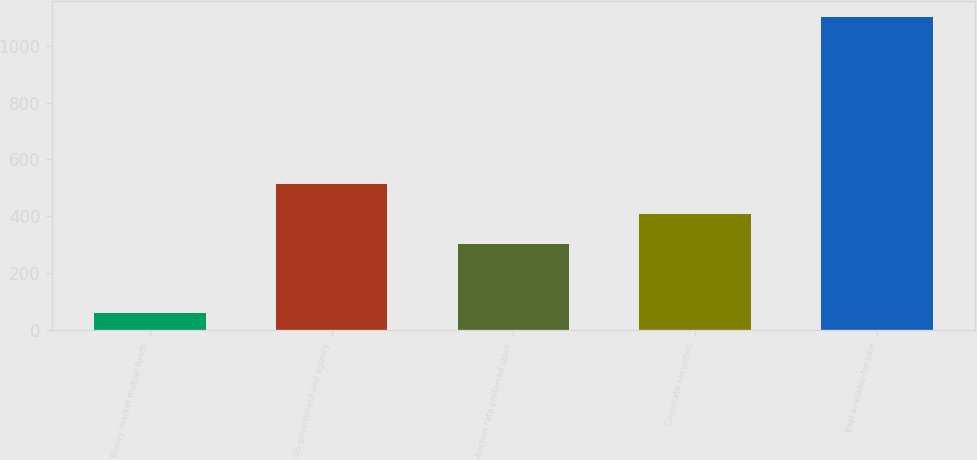Convert chart to OTSL. <chart><loc_0><loc_0><loc_500><loc_500><bar_chart><fcel>Money market mutual funds<fcel>US government and agency<fcel>Auction rate preferred stock<fcel>Corporate securities<fcel>Total available-for-sale<nl><fcel>60<fcel>512<fcel>304<fcel>408<fcel>1100<nl></chart> 